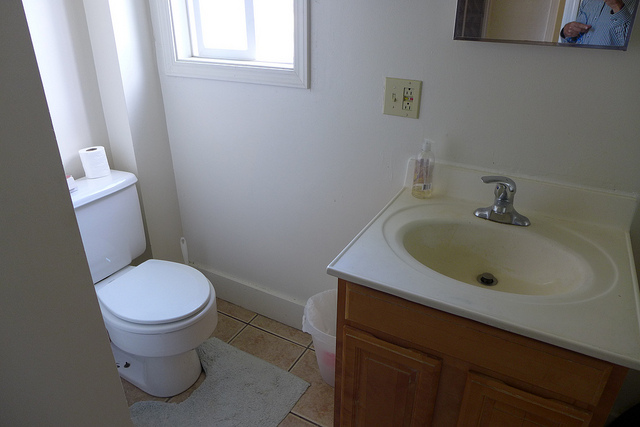Is there any artwork or decoration visible in the bathroom? The bathroom has a minimalistic design with no visible artwork or decorative items in the captured view. 